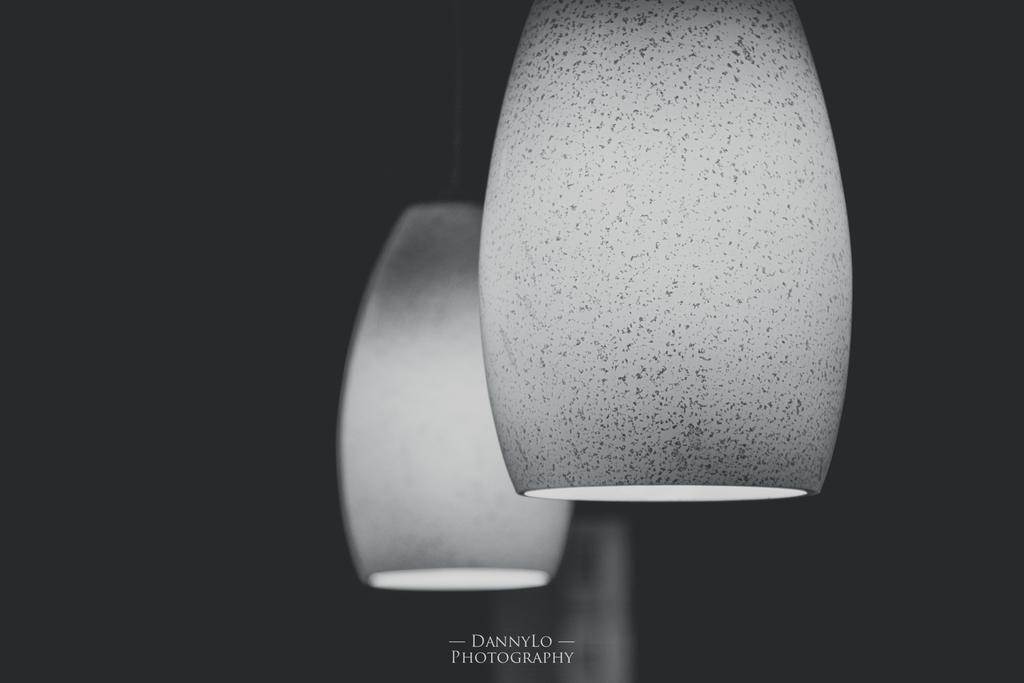In one or two sentences, can you explain what this image depicts? In the middle of the picture we can see decorative objects looking like light. Around them it is dark. At the bottom there is text. 